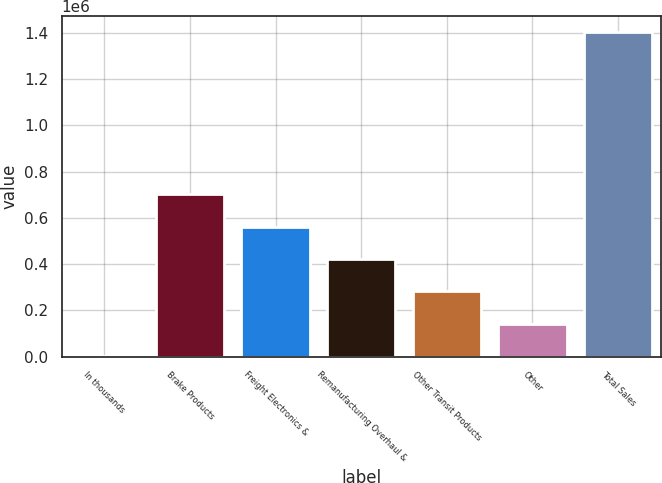Convert chart to OTSL. <chart><loc_0><loc_0><loc_500><loc_500><bar_chart><fcel>In thousands<fcel>Brake Products<fcel>Freight Electronics &<fcel>Remanufacturing Overhaul &<fcel>Other Transit Products<fcel>Other<fcel>Total Sales<nl><fcel>2009<fcel>701812<fcel>561852<fcel>421891<fcel>281930<fcel>141970<fcel>1.40162e+06<nl></chart> 